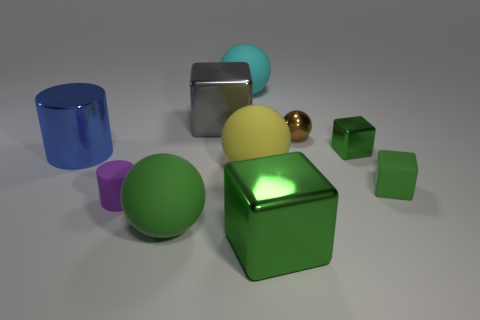What shape is the small rubber thing that is the same color as the tiny metallic cube?
Make the answer very short. Cube. Are there any metallic objects that have the same color as the tiny metal ball?
Offer a very short reply. No. There is a gray block that is on the left side of the small brown metallic object; is it the same size as the green rubber thing behind the tiny purple matte cylinder?
Offer a terse response. No. What is the block that is both behind the green rubber cube and to the right of the big green cube made of?
Give a very brief answer. Metal. What is the size of the matte thing that is the same color as the matte block?
Your response must be concise. Large. What number of other objects are the same size as the gray metallic block?
Your response must be concise. 5. There is a large block that is behind the tiny cylinder; what is its material?
Your answer should be compact. Metal. Is the brown shiny object the same shape as the big green shiny thing?
Provide a succinct answer. No. What number of other objects are there of the same shape as the tiny brown metallic thing?
Give a very brief answer. 3. The matte cylinder behind the green sphere is what color?
Your answer should be very brief. Purple. 